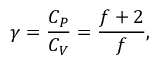<formula> <loc_0><loc_0><loc_500><loc_500>\gamma = { \frac { C _ { P } } { C _ { V } } } = { \frac { f + 2 } { f } } ,</formula> 